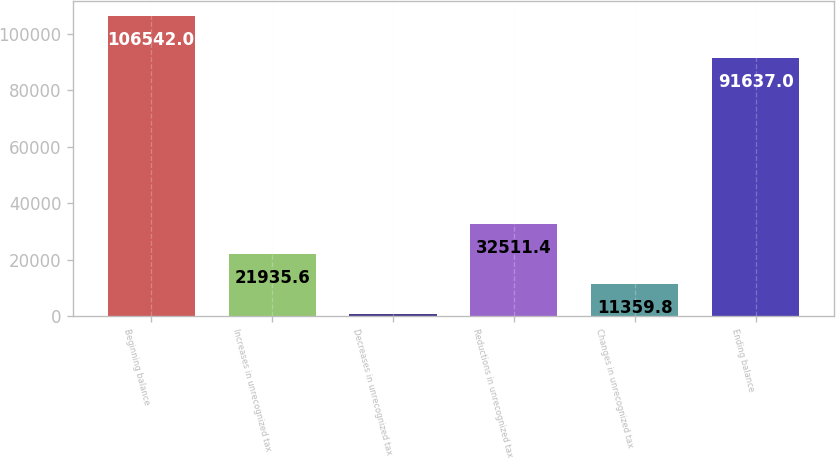Convert chart to OTSL. <chart><loc_0><loc_0><loc_500><loc_500><bar_chart><fcel>Beginning balance<fcel>Increases in unrecognized tax<fcel>Decreases in unrecognized tax<fcel>Reductions in unrecognized tax<fcel>Changes in unrecognized tax<fcel>Ending balance<nl><fcel>106542<fcel>21935.6<fcel>784<fcel>32511.4<fcel>11359.8<fcel>91637<nl></chart> 